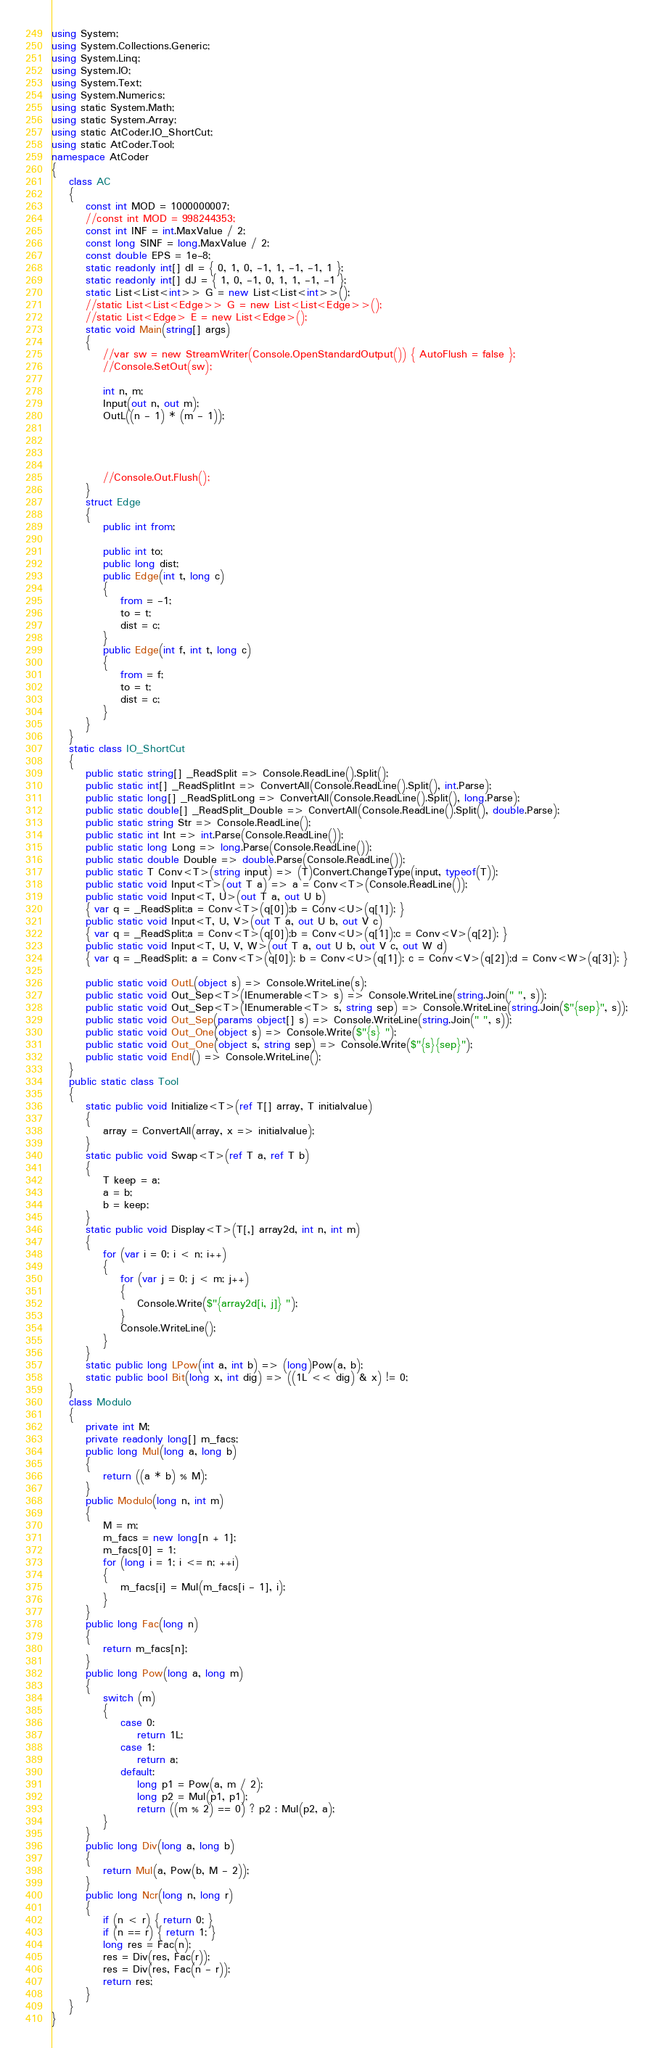<code> <loc_0><loc_0><loc_500><loc_500><_C#_>using System;
using System.Collections.Generic;
using System.Linq;
using System.IO;
using System.Text;
using System.Numerics;
using static System.Math;
using static System.Array;
using static AtCoder.IO_ShortCut;
using static AtCoder.Tool;
namespace AtCoder
{
    class AC
    {
        const int MOD = 1000000007;
        //const int MOD = 998244353;
        const int INF = int.MaxValue / 2;
        const long SINF = long.MaxValue / 2;
        const double EPS = 1e-8;
        static readonly int[] dI = { 0, 1, 0, -1, 1, -1, -1, 1 };
        static readonly int[] dJ = { 1, 0, -1, 0, 1, 1, -1, -1 };
        static List<List<int>> G = new List<List<int>>();
        //static List<List<Edge>> G = new List<List<Edge>>();
        //static List<Edge> E = new List<Edge>();
        static void Main(string[] args)
        {
            //var sw = new StreamWriter(Console.OpenStandardOutput()) { AutoFlush = false };
            //Console.SetOut(sw);

            int n, m;
            Input(out n, out m);
            OutL((n - 1) * (m - 1));

            
            

            //Console.Out.Flush();
        }
        struct Edge
        {
            public int from;

            public int to;
            public long dist;
            public Edge(int t, long c)
            {
                from = -1;
                to = t;
                dist = c;
            }
            public Edge(int f, int t, long c)
            {
                from = f;
                to = t;
                dist = c;
            }
        }
    }
    static class IO_ShortCut
    {
        public static string[] _ReadSplit => Console.ReadLine().Split();
        public static int[] _ReadSplitInt => ConvertAll(Console.ReadLine().Split(), int.Parse);
        public static long[] _ReadSplitLong => ConvertAll(Console.ReadLine().Split(), long.Parse);
        public static double[] _ReadSplit_Double => ConvertAll(Console.ReadLine().Split(), double.Parse);
        public static string Str => Console.ReadLine();
        public static int Int => int.Parse(Console.ReadLine());
        public static long Long => long.Parse(Console.ReadLine());
        public static double Double => double.Parse(Console.ReadLine());
        public static T Conv<T>(string input) => (T)Convert.ChangeType(input, typeof(T));
        public static void Input<T>(out T a) => a = Conv<T>(Console.ReadLine());
        public static void Input<T, U>(out T a, out U b)
        { var q = _ReadSplit;a = Conv<T>(q[0]);b = Conv<U>(q[1]); }
        public static void Input<T, U, V>(out T a, out U b, out V c)
        { var q = _ReadSplit;a = Conv<T>(q[0]);b = Conv<U>(q[1]);c = Conv<V>(q[2]); }
        public static void Input<T, U, V, W>(out T a, out U b, out V c, out W d)
        { var q = _ReadSplit; a = Conv<T>(q[0]); b = Conv<U>(q[1]); c = Conv<V>(q[2]);d = Conv<W>(q[3]); }

        public static void OutL(object s) => Console.WriteLine(s);
        public static void Out_Sep<T>(IEnumerable<T> s) => Console.WriteLine(string.Join(" ", s));
        public static void Out_Sep<T>(IEnumerable<T> s, string sep) => Console.WriteLine(string.Join($"{sep}", s));
        public static void Out_Sep(params object[] s) => Console.WriteLine(string.Join(" ", s));
        public static void Out_One(object s) => Console.Write($"{s} ");
        public static void Out_One(object s, string sep) => Console.Write($"{s}{sep}");
        public static void Endl() => Console.WriteLine();
    }
    public static class Tool
    {
        static public void Initialize<T>(ref T[] array, T initialvalue)
        {
            array = ConvertAll(array, x => initialvalue);
        }
        static public void Swap<T>(ref T a, ref T b)
        {
            T keep = a;
            a = b;
            b = keep;
        }
        static public void Display<T>(T[,] array2d, int n, int m)
        {
            for (var i = 0; i < n; i++)
            {
                for (var j = 0; j < m; j++)
                {
                    Console.Write($"{array2d[i, j]} ");
                }
                Console.WriteLine();
            }
        }
        static public long LPow(int a, int b) => (long)Pow(a, b);
        static public bool Bit(long x, int dig) => ((1L << dig) & x) != 0;
    }
    class Modulo
    {
        private int M;
        private readonly long[] m_facs;
        public long Mul(long a, long b)
        {
            return ((a * b) % M);
        }
        public Modulo(long n, int m)
        {
            M = m;
            m_facs = new long[n + 1];
            m_facs[0] = 1;
            for (long i = 1; i <= n; ++i)
            {
                m_facs[i] = Mul(m_facs[i - 1], i);
            }
        }
        public long Fac(long n)
        {
            return m_facs[n];
        }
        public long Pow(long a, long m)
        {
            switch (m)
            {
                case 0:
                    return 1L;
                case 1:
                    return a;
                default:
                    long p1 = Pow(a, m / 2);
                    long p2 = Mul(p1, p1);
                    return ((m % 2) == 0) ? p2 : Mul(p2, a);
            }
        }
        public long Div(long a, long b)
        {
            return Mul(a, Pow(b, M - 2));
        }
        public long Ncr(long n, long r)
        {
            if (n < r) { return 0; }
            if (n == r) { return 1; }
            long res = Fac(n);
            res = Div(res, Fac(r));
            res = Div(res, Fac(n - r));
            return res;
        }
    }
}
</code> 